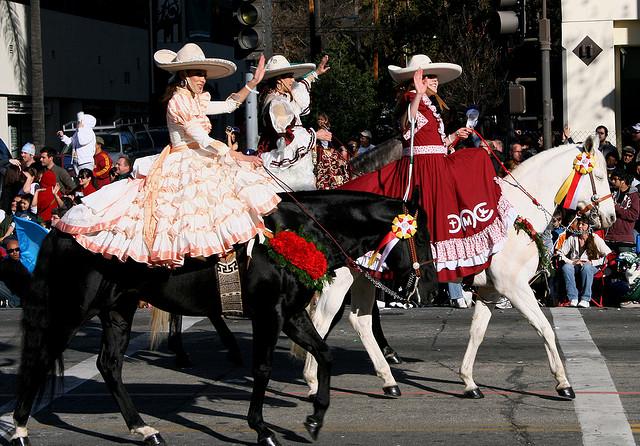What color is the lead horse?
Quick response, please. White. Are they in formal wear?
Answer briefly. Yes. Are the women waving?
Be succinct. Yes. 